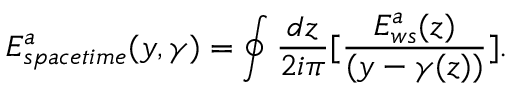Convert formula to latex. <formula><loc_0><loc_0><loc_500><loc_500>E _ { s p a c e t i m e } ^ { a } ( y , \gamma ) = \oint { \frac { d z } { 2 i \pi } } [ { \frac { E _ { w s } ^ { a } ( z ) } { ( y - \gamma ( z ) ) } } ] .</formula> 